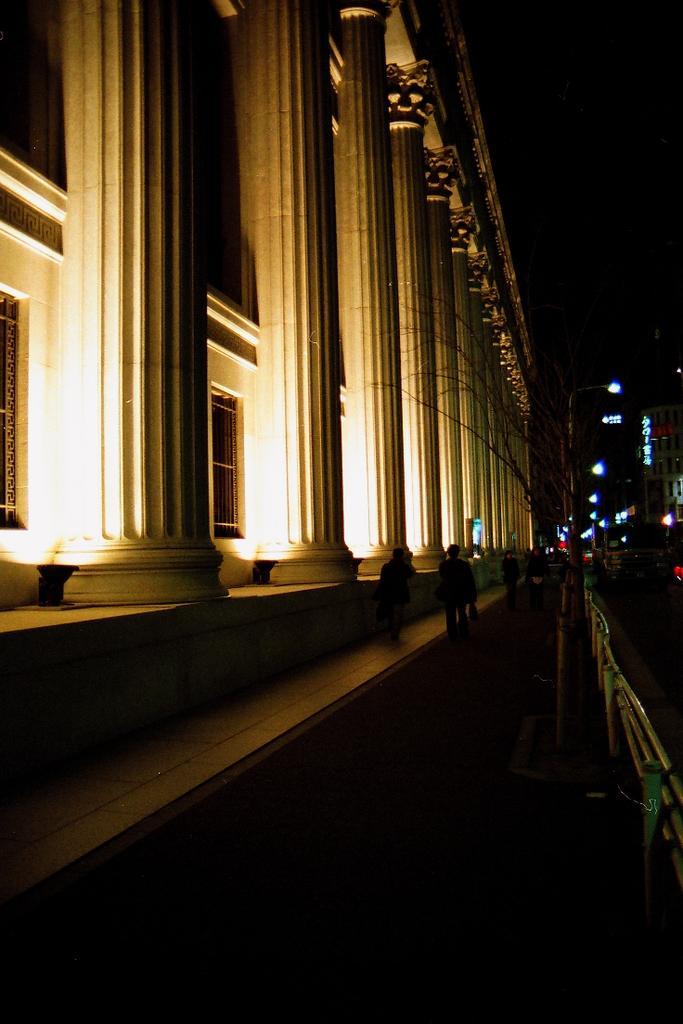How would you summarize this image in a sentence or two? In this image we can see people, fence, lights, poles, pillars, and buildings. There is a dark background. 